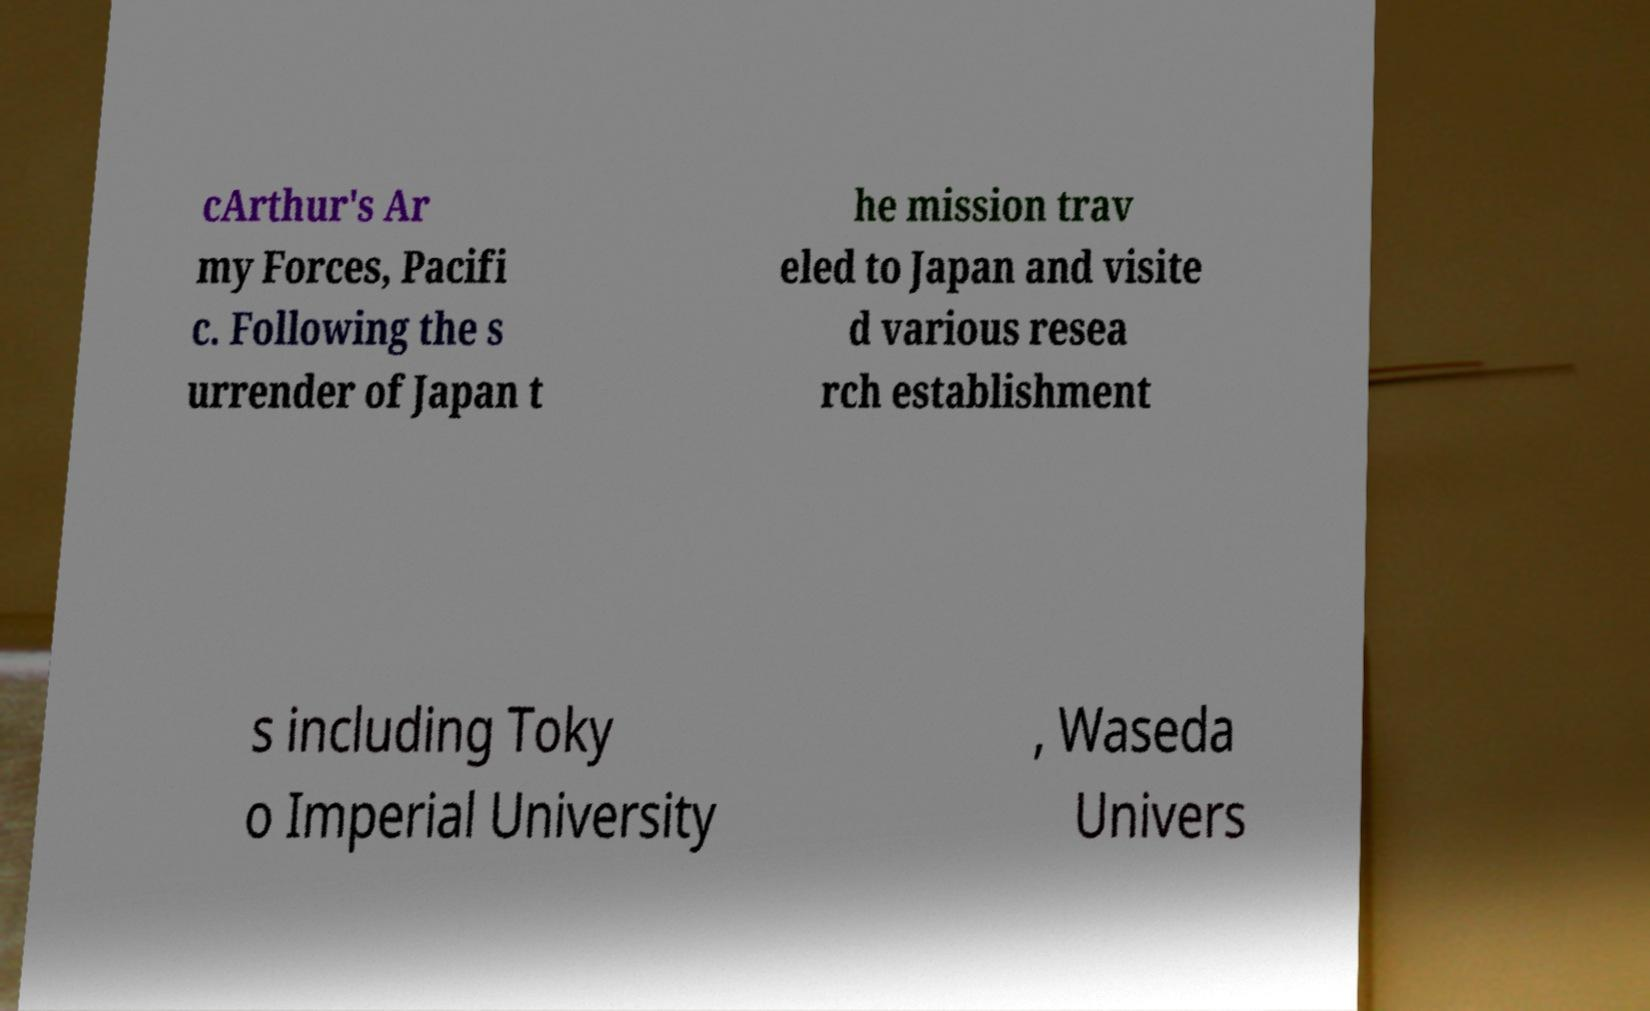Please read and relay the text visible in this image. What does it say? cArthur's Ar my Forces, Pacifi c. Following the s urrender of Japan t he mission trav eled to Japan and visite d various resea rch establishment s including Toky o Imperial University , Waseda Univers 